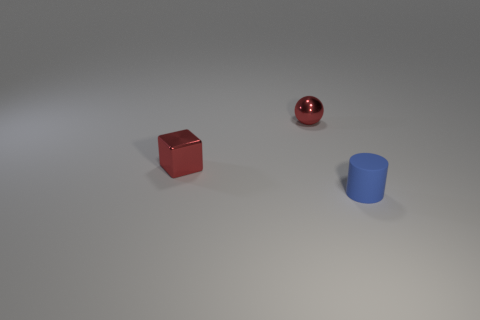Subtract all blocks. How many objects are left? 2 Add 1 small blue cylinders. How many objects exist? 4 Subtract all small red shiny balls. Subtract all small blue objects. How many objects are left? 1 Add 1 small blue cylinders. How many small blue cylinders are left? 2 Add 1 small cyan metallic blocks. How many small cyan metallic blocks exist? 1 Subtract 0 red cylinders. How many objects are left? 3 Subtract 1 balls. How many balls are left? 0 Subtract all cyan balls. Subtract all blue blocks. How many balls are left? 1 